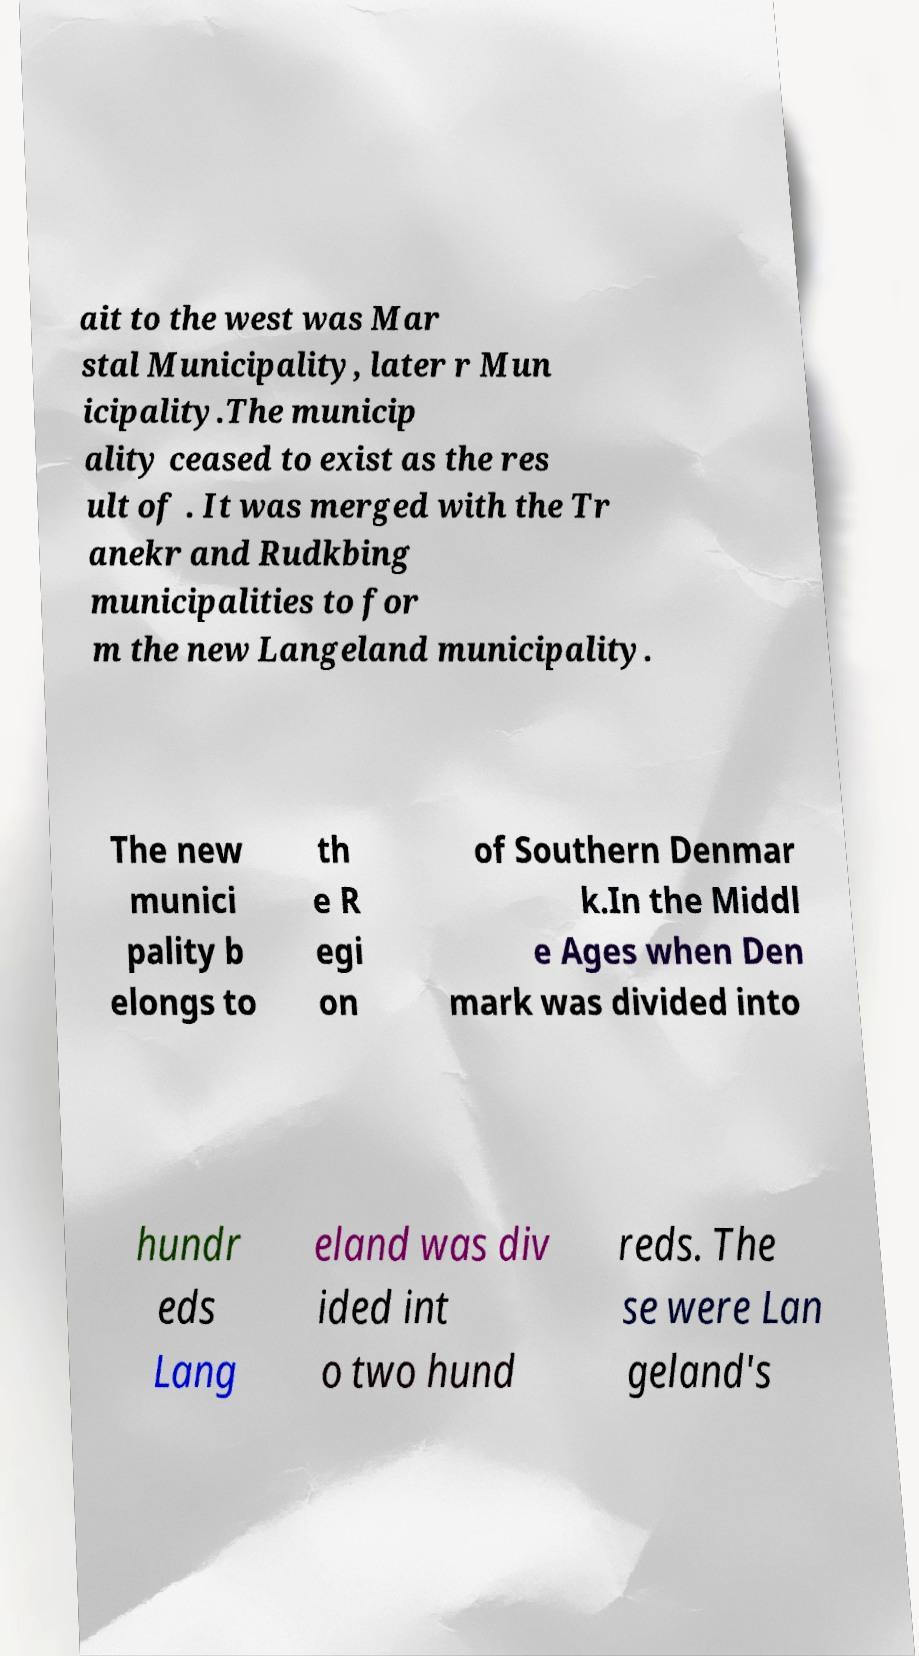I need the written content from this picture converted into text. Can you do that? ait to the west was Mar stal Municipality, later r Mun icipality.The municip ality ceased to exist as the res ult of . It was merged with the Tr anekr and Rudkbing municipalities to for m the new Langeland municipality. The new munici pality b elongs to th e R egi on of Southern Denmar k.In the Middl e Ages when Den mark was divided into hundr eds Lang eland was div ided int o two hund reds. The se were Lan geland's 